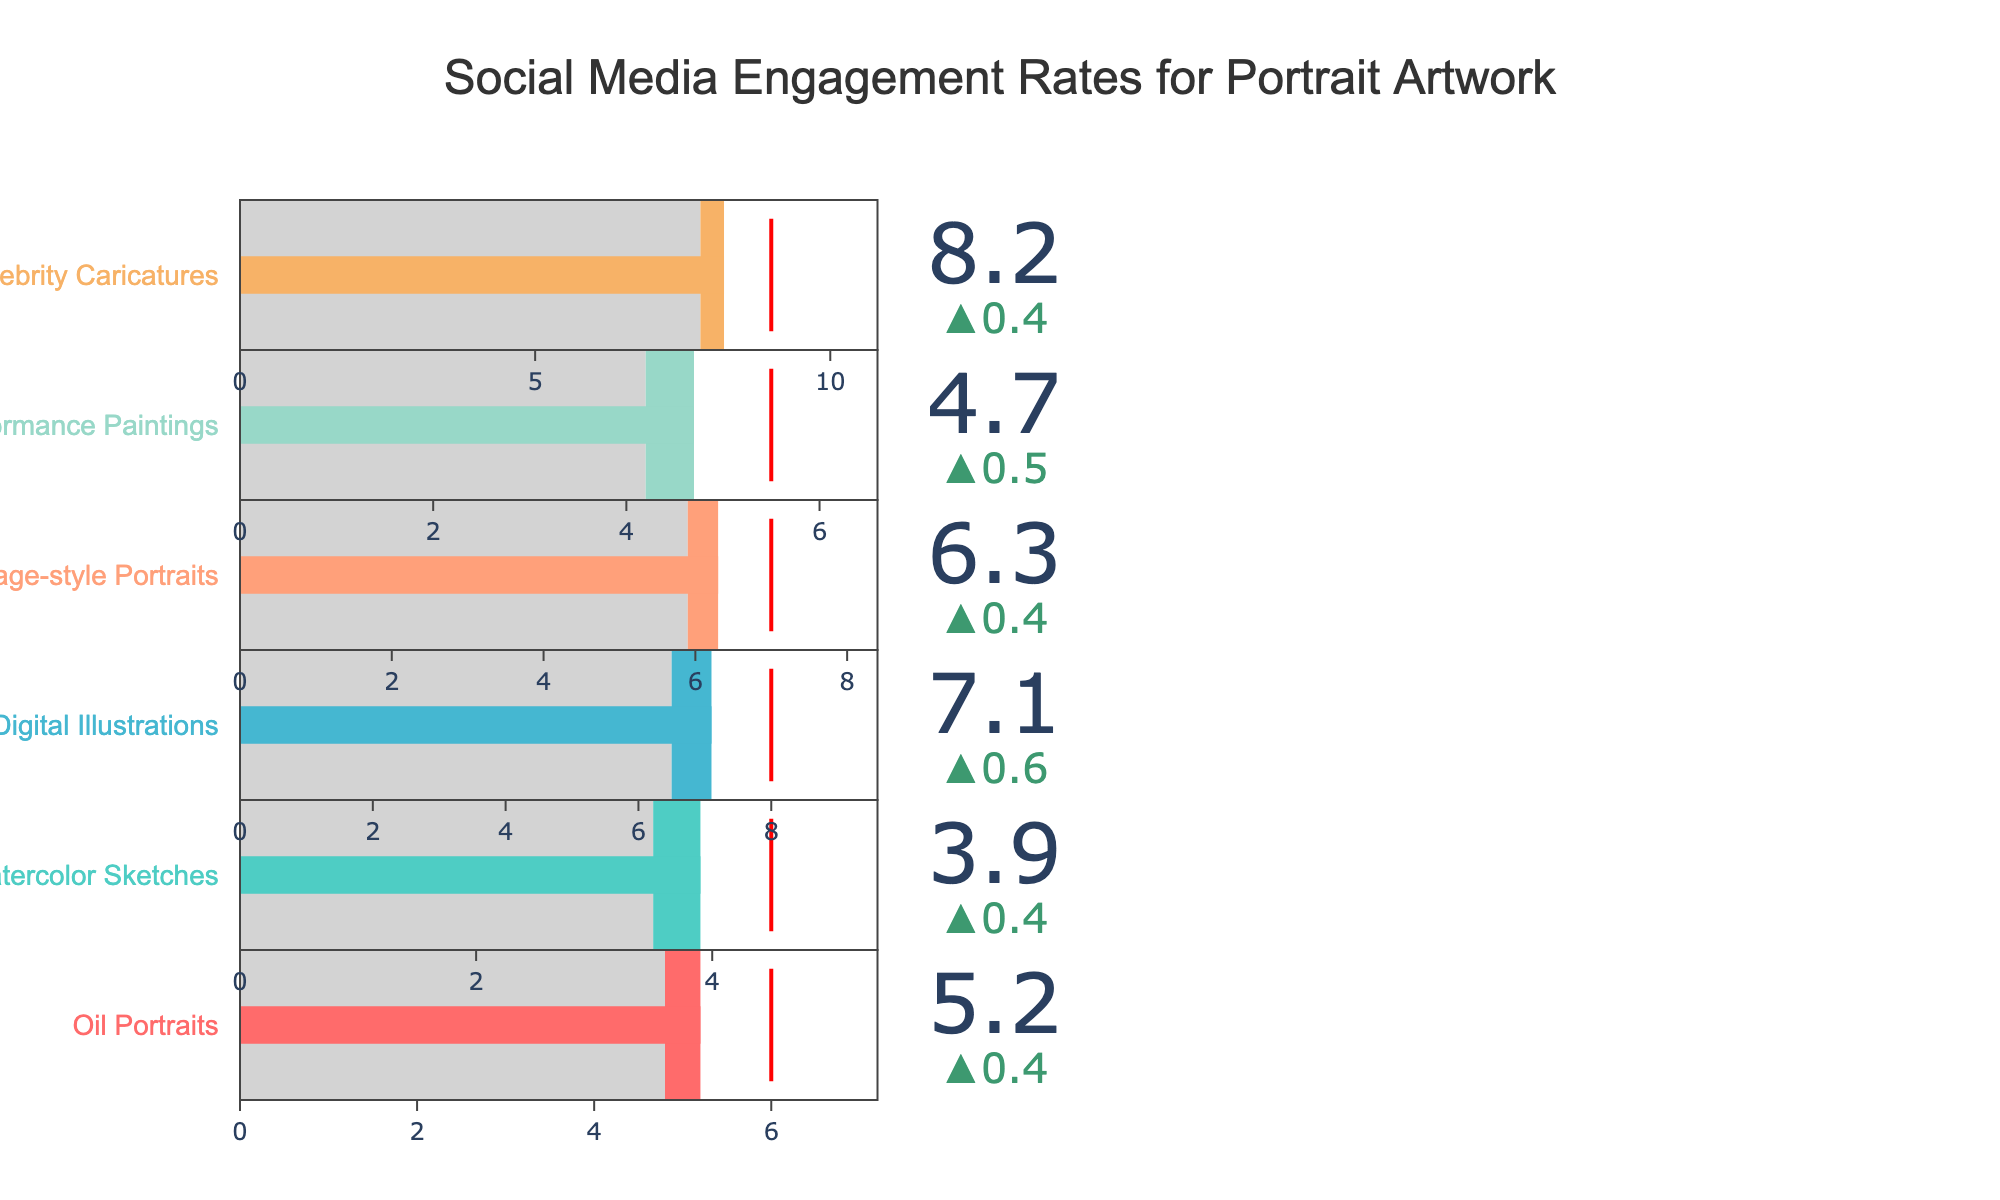What category has the highest actual engagement rate? Look for the highest value in the "Actual" column. The highest value is 8.2, which corresponds to "Celebrity Caricatures".
Answer: Celebrity Caricatures What is the title of the chart? Read the title located at the top of the chart. It provides a direct description of what the chart represents.
Answer: Social Media Engagement Rates for Portrait Artwork Which category is closest to hitting its target engagement rate? Compare the "Actual" and "Target" values for each category and see which difference is the smallest. "Oil Portraits" has a target of 6.0 and an actual of 5.2, a difference of 0.8. Similarly, "Celebrity Caricatures" has a target of 9.0 and an actual of 8.2, with a difference of 0.8. Both categories are equally distant from their targets.
Answer: Oil Portraits and Celebrity Caricatures What is the engagement rate for Digital Illustrations? Look at the value listed under the "Actual" column for "Digital Illustrations". It is 7.1.
Answer: 7.1 How much higher is the actual engagement rate for Stage Performance Paintings compared to its comparative engagement rate? Subtract the "Comparative" value from the "Actual" value for "Stage Performance Paintings". 4.7 (Actual) - 4.2 (Comparative) = 0.5.
Answer: 0.5 Which categories exceeded their comparative engagement rates? Compare the "Actual" and "Comparative" values for each category. Categories where the "Actual" value is greater than the "Comparative" value are "Oil Portraits", "Watercolor Sketches", "Digital Illustrations", "Vintage-style Portraits", "Stage Performance Paintings", and "Celebrity Caricatures".
Answer: Oil Portraits, Watercolor Sketches, Digital Illustrations, Vintage-style Portraits, Stage Performance Paintings, Celebrity Caricatures What is the average actual engagement rate across all categories? Sum all the "Actual" values and divide by the number of categories. (5.2 + 3.9 + 7.1 + 6.3 + 4.7 + 8.2) / 6 = 5.90.
Answer: 5.90 Is the target engagement rate for Watercolor Sketches higher than the target for Stage Performance Paintings? Compare the "Target" values for both categories. The target for Watercolor Sketches is 4.5, and the target for Stage Performance Paintings is 5.5, so Watercolor Sketches has a lower target.
Answer: No Which category has the lowest comparative engagement rate? Look for the lowest value in the "Comparative" column. The lowest value is 3.5, which corresponds to "Watercolor Sketches".
Answer: Watercolor Sketches 